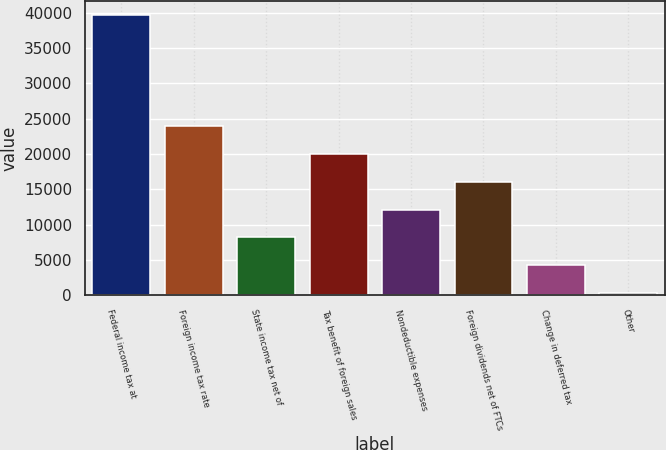Convert chart. <chart><loc_0><loc_0><loc_500><loc_500><bar_chart><fcel>Federal income tax at<fcel>Foreign income tax rate<fcel>State income tax net of<fcel>Tax benefit of foreign sales<fcel>Nondeductible expenses<fcel>Foreign dividends net of FTCs<fcel>Change in deferred tax<fcel>Other<nl><fcel>39668<fcel>23917.6<fcel>8167.2<fcel>19980<fcel>12104.8<fcel>16042.4<fcel>4229.6<fcel>292<nl></chart> 